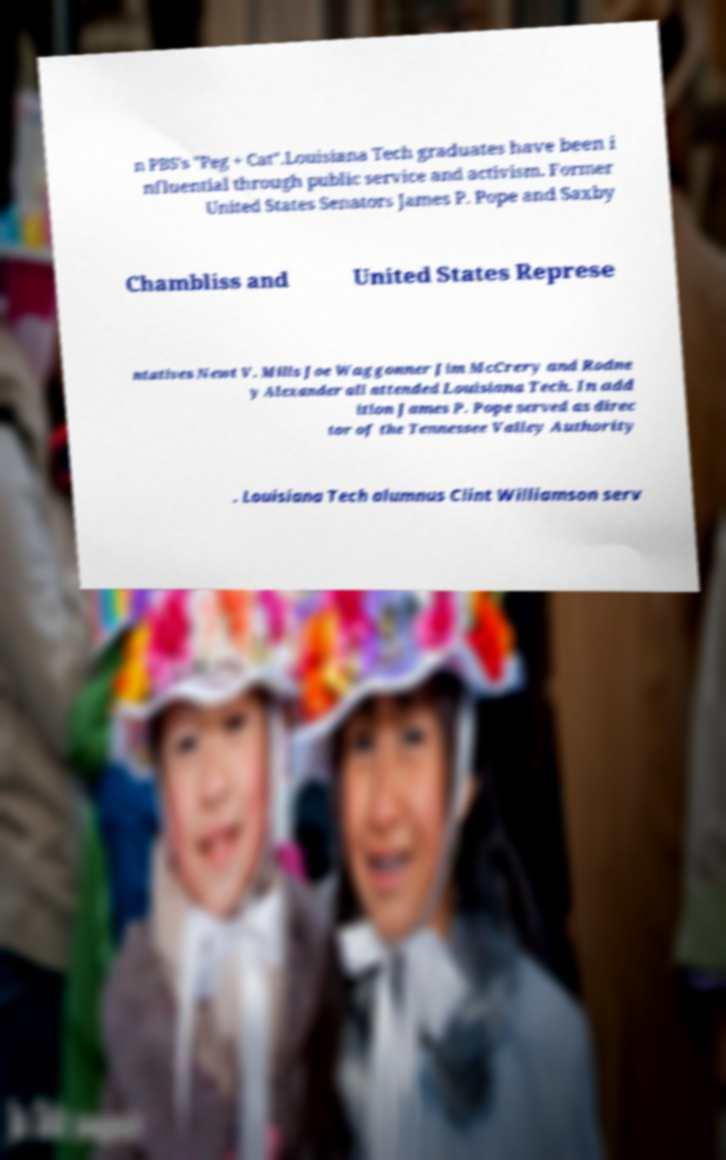What messages or text are displayed in this image? I need them in a readable, typed format. n PBS's "Peg + Cat".Louisiana Tech graduates have been i nfluential through public service and activism. Former United States Senators James P. Pope and Saxby Chambliss and United States Represe ntatives Newt V. Mills Joe Waggonner Jim McCrery and Rodne y Alexander all attended Louisiana Tech. In add ition James P. Pope served as direc tor of the Tennessee Valley Authority . Louisiana Tech alumnus Clint Williamson serv 